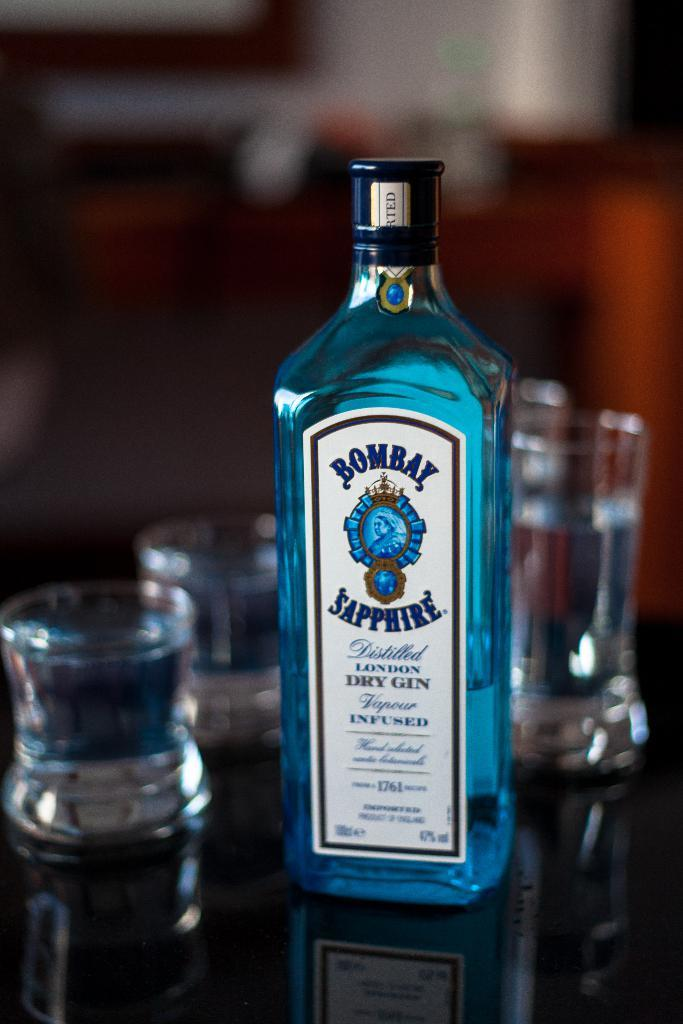<image>
Relay a brief, clear account of the picture shown. A bottle of Bombay Sapphire has a blue tone and contains 47% alcohol. 